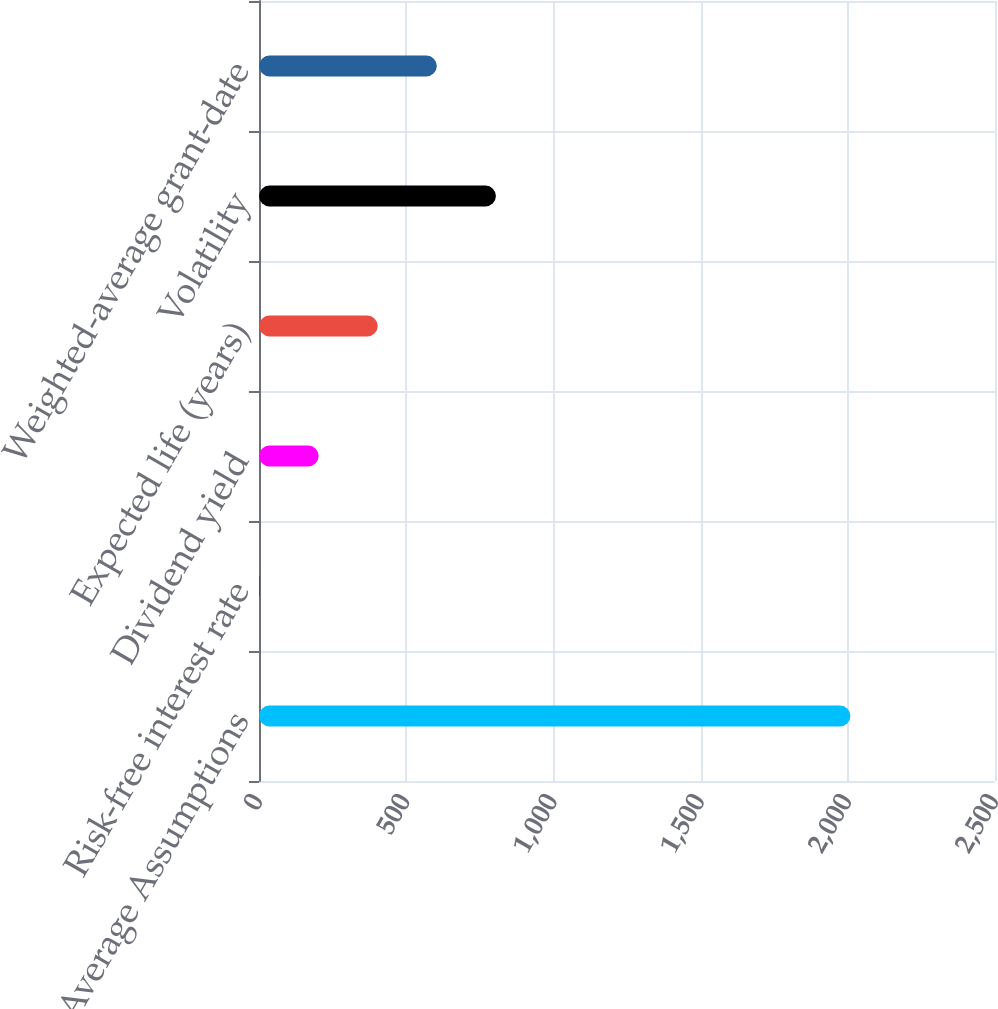Convert chart to OTSL. <chart><loc_0><loc_0><loc_500><loc_500><bar_chart><fcel>Weighted-Average Assumptions<fcel>Risk-free interest rate<fcel>Dividend yield<fcel>Expected life (years)<fcel>Volatility<fcel>Weighted-average grant-date<nl><fcel>2009<fcel>1.9<fcel>202.61<fcel>403.32<fcel>804.74<fcel>604.03<nl></chart> 